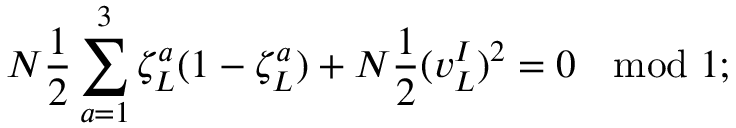<formula> <loc_0><loc_0><loc_500><loc_500>N \frac { 1 } { 2 } \sum _ { a = 1 } ^ { 3 } \zeta _ { L } ^ { a } ( 1 - \zeta _ { L } ^ { a } ) + N \frac { 1 } { 2 } ( v _ { L } ^ { I } ) ^ { 2 } = 0 \quad b m o d 1 ;</formula> 